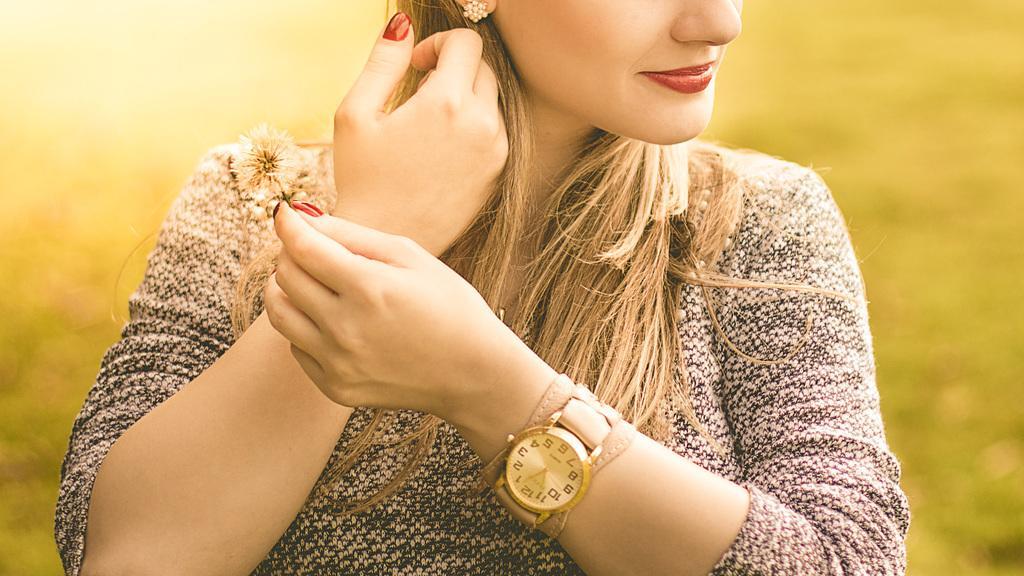Can you describe this image briefly? In this image there is a woman who is a watch to her hand and nail polish to her fingers. 